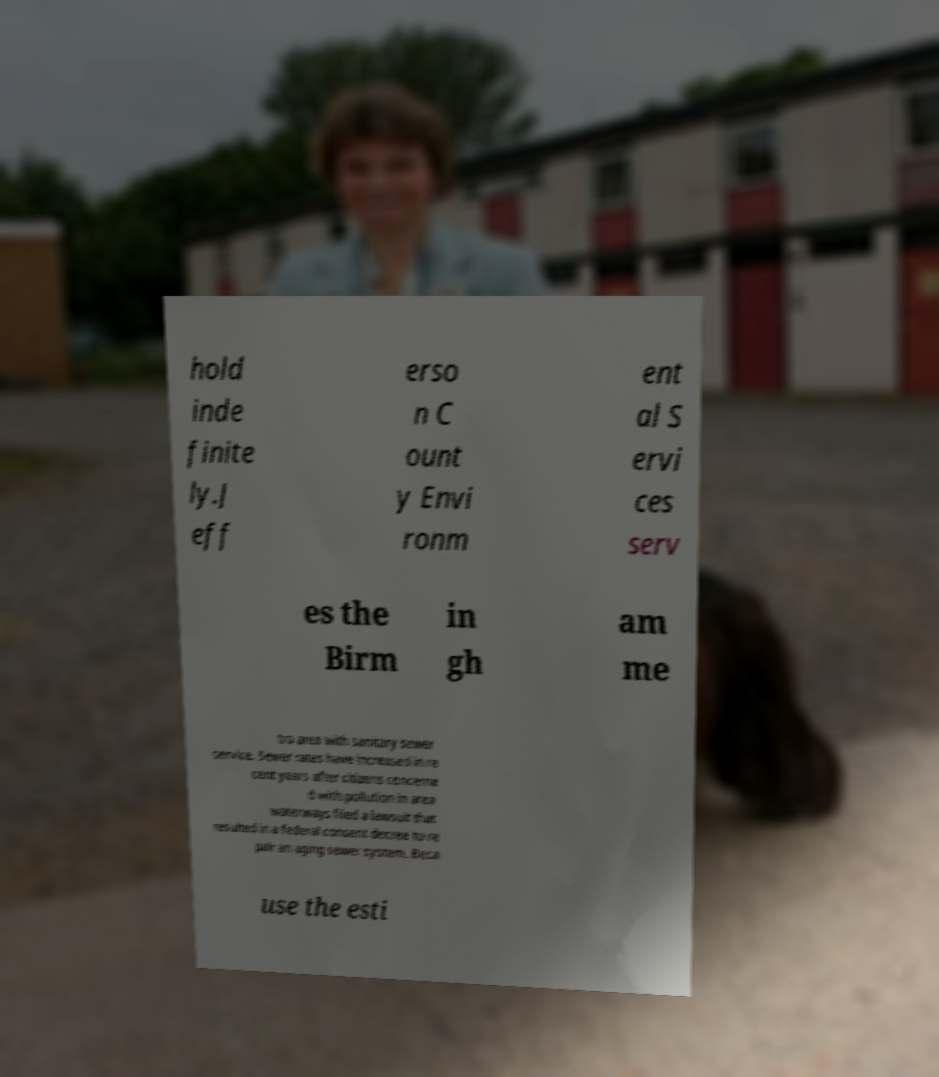I need the written content from this picture converted into text. Can you do that? hold inde finite ly.J eff erso n C ount y Envi ronm ent al S ervi ces serv es the Birm in gh am me tro area with sanitary sewer service. Sewer rates have increased in re cent years after citizens concerne d with pollution in area waterways filed a lawsuit that resulted in a federal consent decree to re pair an aging sewer system. Beca use the esti 